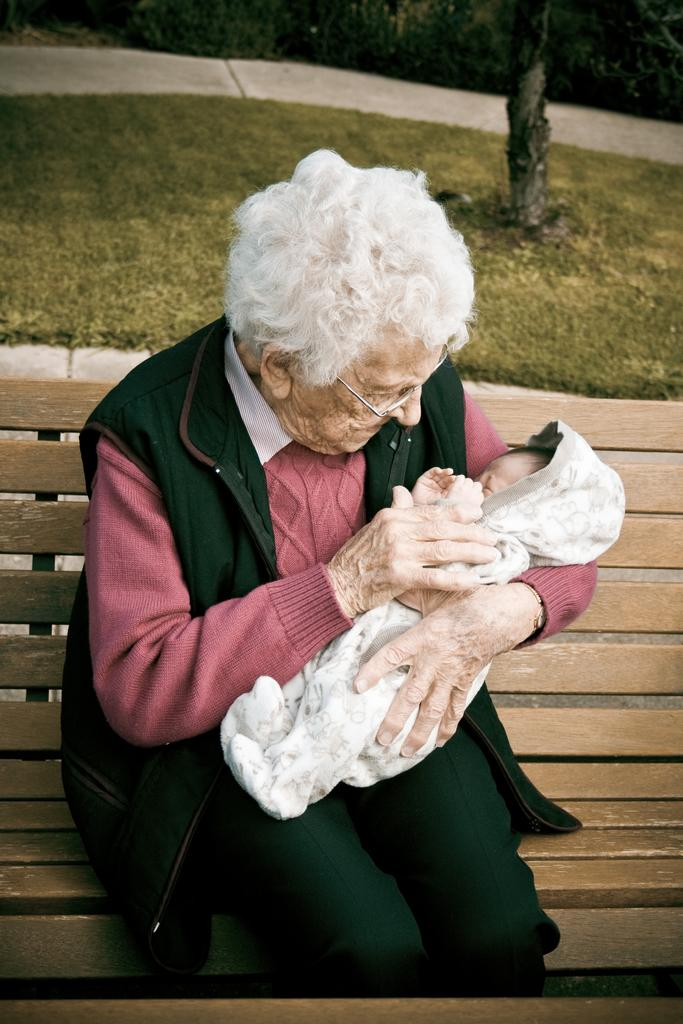Who is present in the image? There is a person in the image. What is the person doing in the image? The person is holding a child. Where are the person and the child sitting? Both the person and the child are sitting on a bench. What type of environment is visible in the image? There is grass in the image. What type of prose is the person reading to the child in the image? There is no indication in the image that the person is reading any prose to the child. 